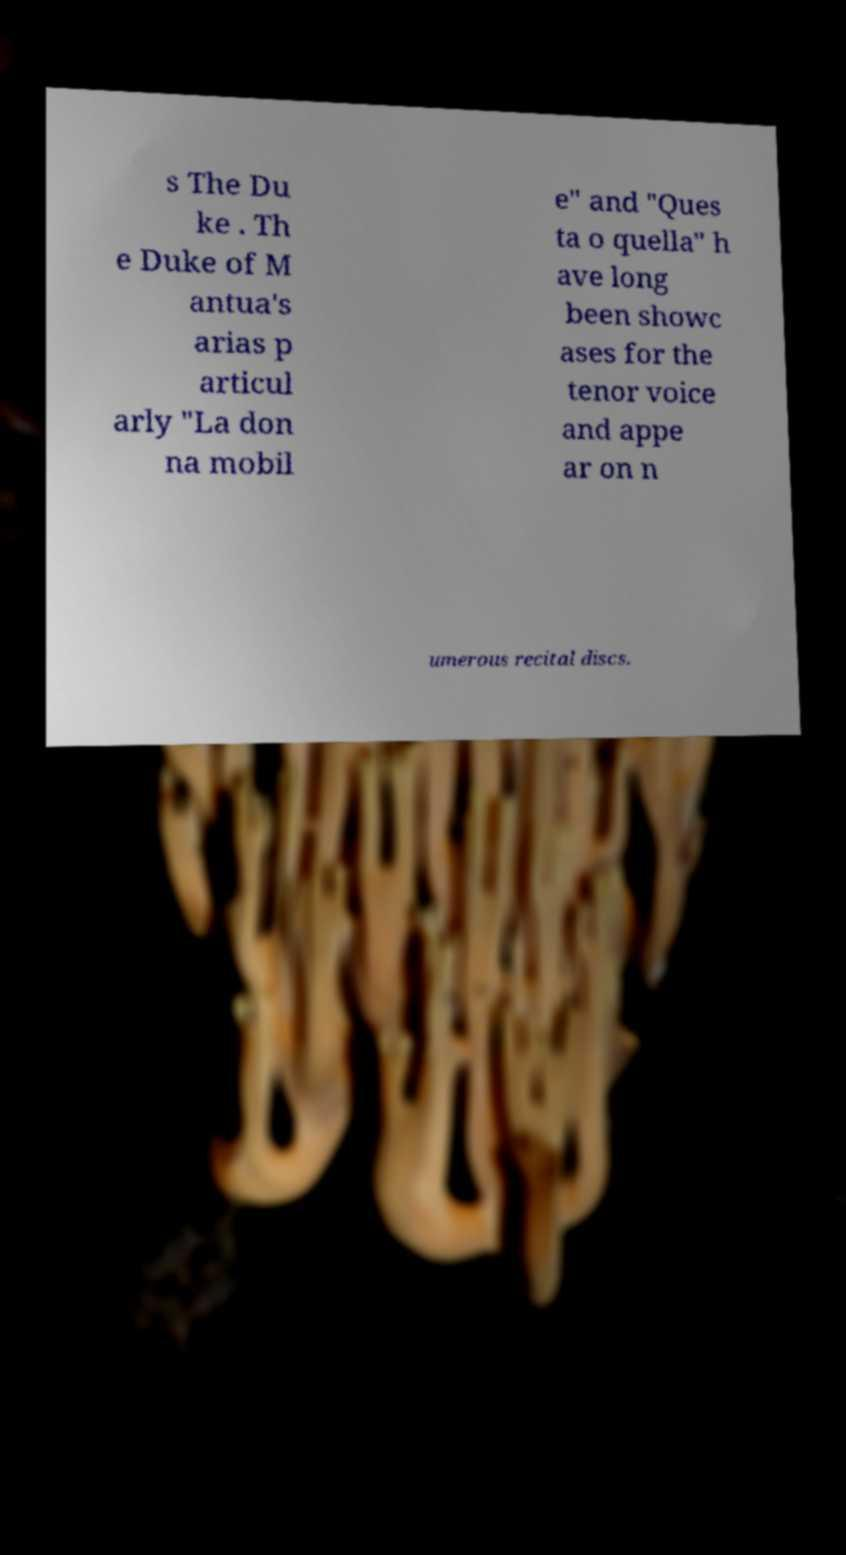I need the written content from this picture converted into text. Can you do that? s The Du ke . Th e Duke of M antua's arias p articul arly "La don na mobil e" and "Ques ta o quella" h ave long been showc ases for the tenor voice and appe ar on n umerous recital discs. 